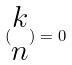<formula> <loc_0><loc_0><loc_500><loc_500>( \begin{matrix} k \\ n \end{matrix} ) = 0</formula> 